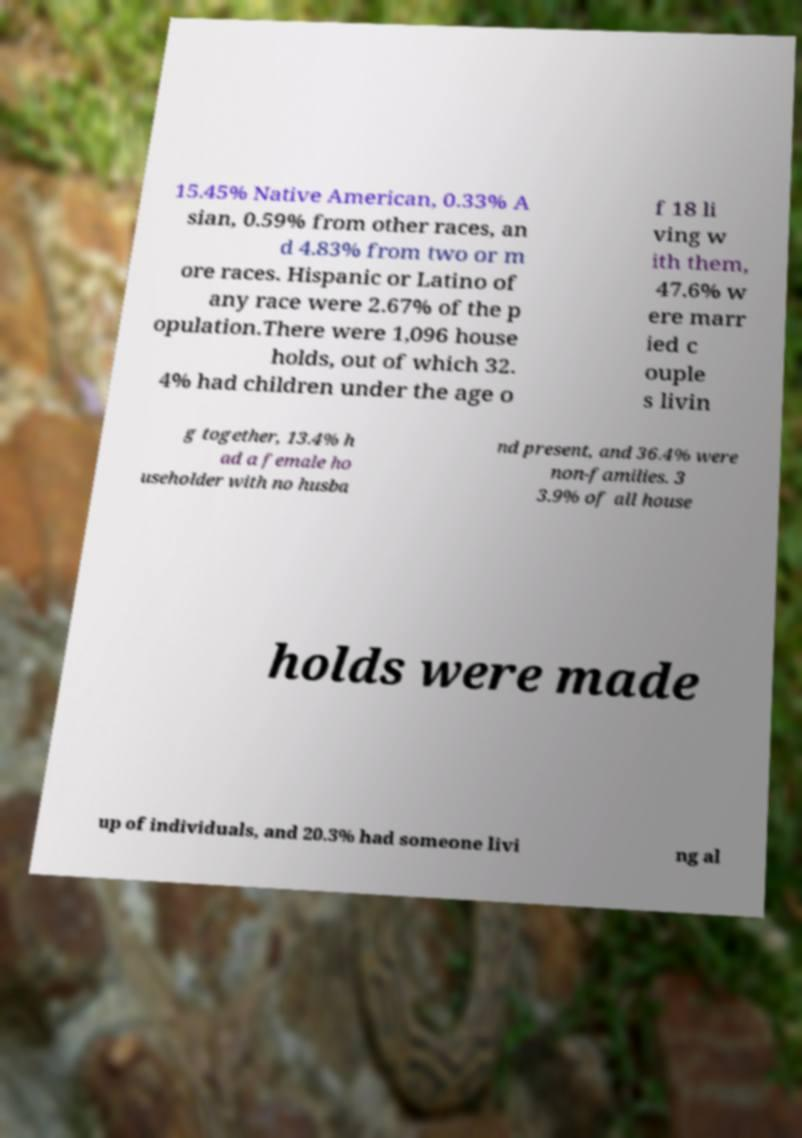Could you assist in decoding the text presented in this image and type it out clearly? 15.45% Native American, 0.33% A sian, 0.59% from other races, an d 4.83% from two or m ore races. Hispanic or Latino of any race were 2.67% of the p opulation.There were 1,096 house holds, out of which 32. 4% had children under the age o f 18 li ving w ith them, 47.6% w ere marr ied c ouple s livin g together, 13.4% h ad a female ho useholder with no husba nd present, and 36.4% were non-families. 3 3.9% of all house holds were made up of individuals, and 20.3% had someone livi ng al 